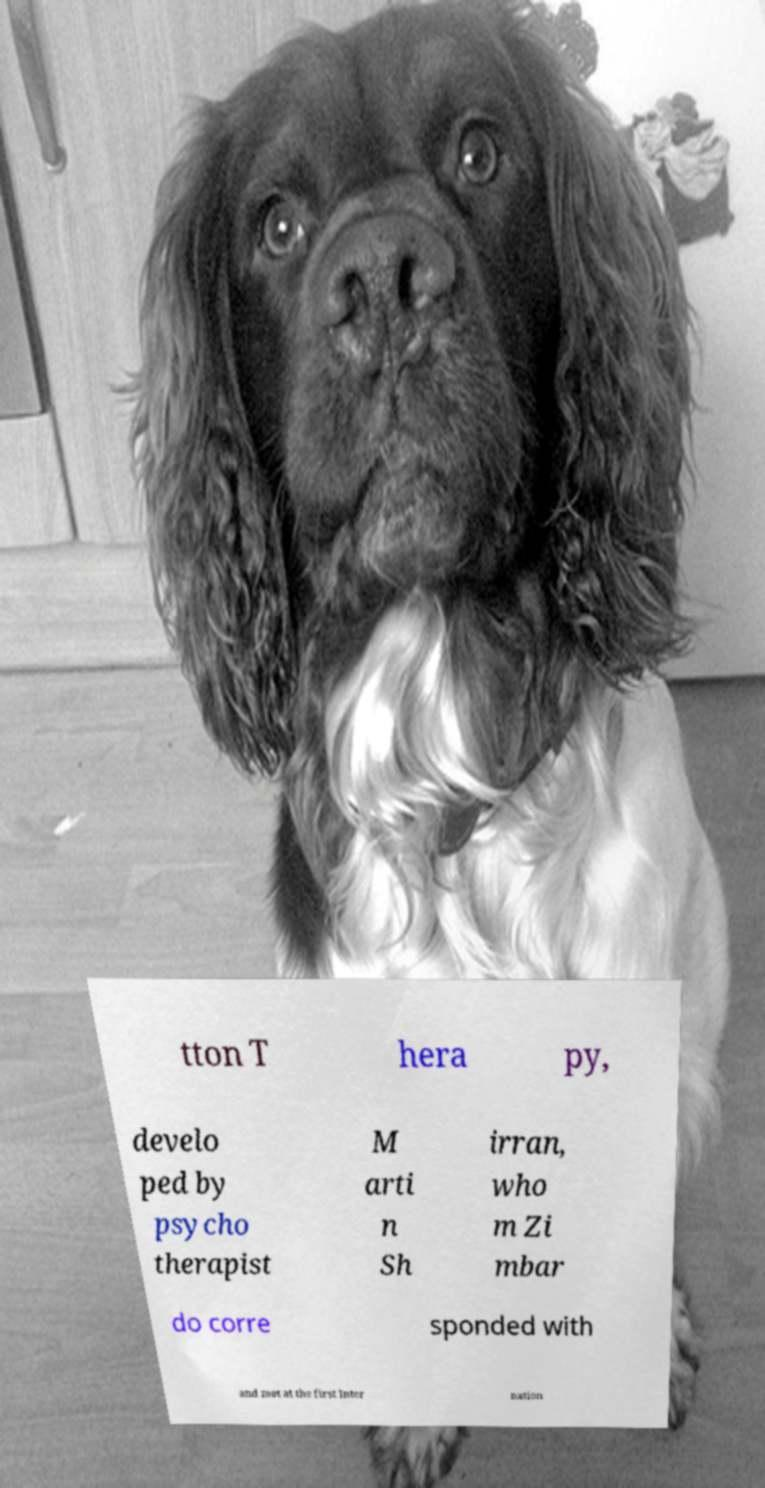Can you read and provide the text displayed in the image?This photo seems to have some interesting text. Can you extract and type it out for me? tton T hera py, develo ped by psycho therapist M arti n Sh irran, who m Zi mbar do corre sponded with and met at the first Inter nation 